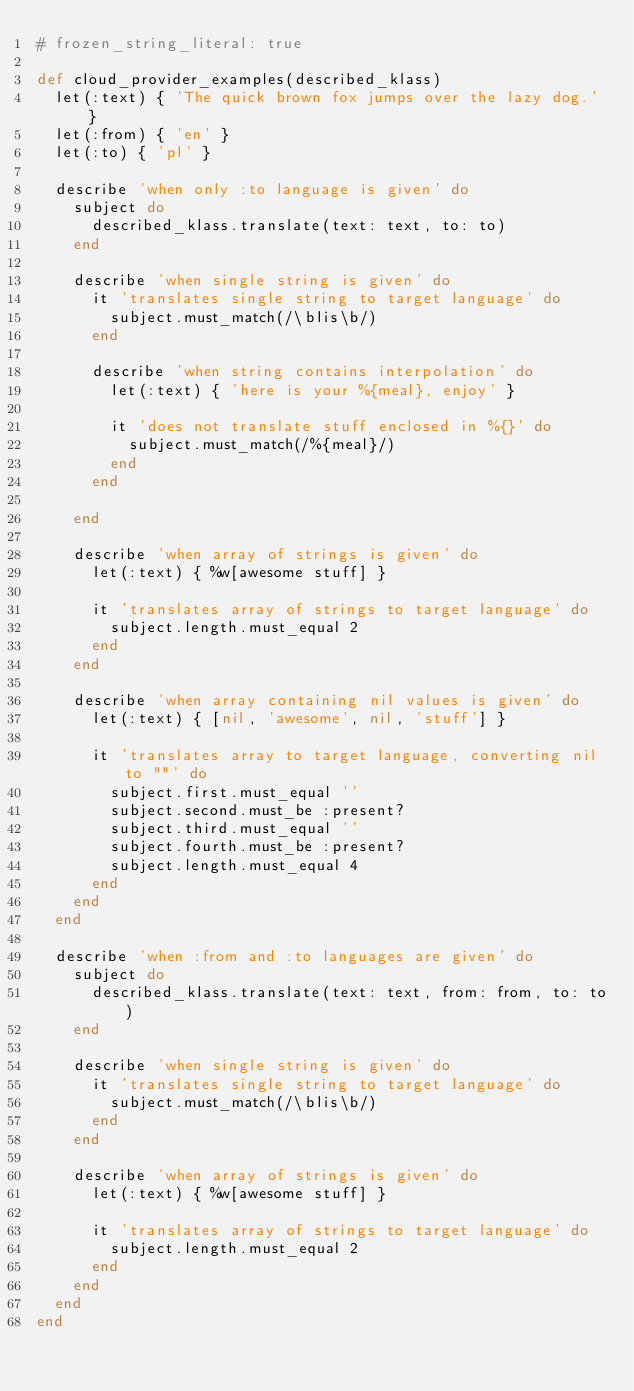Convert code to text. <code><loc_0><loc_0><loc_500><loc_500><_Ruby_># frozen_string_literal: true

def cloud_provider_examples(described_klass)
  let(:text) { 'The quick brown fox jumps over the lazy dog.' }
  let(:from) { 'en' }
  let(:to) { 'pl' }

  describe 'when only :to language is given' do
    subject do
      described_klass.translate(text: text, to: to)
    end

    describe 'when single string is given' do
      it 'translates single string to target language' do
        subject.must_match(/\blis\b/)
      end

      describe 'when string contains interpolation' do
        let(:text) { 'here is your %{meal}, enjoy' }

        it 'does not translate stuff enclosed in %{}' do
          subject.must_match(/%{meal}/)
        end
      end

    end

    describe 'when array of strings is given' do
      let(:text) { %w[awesome stuff] }

      it 'translates array of strings to target language' do
        subject.length.must_equal 2
      end
    end

    describe 'when array containing nil values is given' do
      let(:text) { [nil, 'awesome', nil, 'stuff'] }

      it 'translates array to target language, converting nil to ""' do
        subject.first.must_equal ''
        subject.second.must_be :present?
        subject.third.must_equal ''
        subject.fourth.must_be :present?
        subject.length.must_equal 4
      end
    end
  end

  describe 'when :from and :to languages are given' do
    subject do
      described_klass.translate(text: text, from: from, to: to)
    end

    describe 'when single string is given' do
      it 'translates single string to target language' do
        subject.must_match(/\blis\b/)
      end
    end

    describe 'when array of strings is given' do
      let(:text) { %w[awesome stuff] }

      it 'translates array of strings to target language' do
        subject.length.must_equal 2
      end
    end
  end
end
</code> 